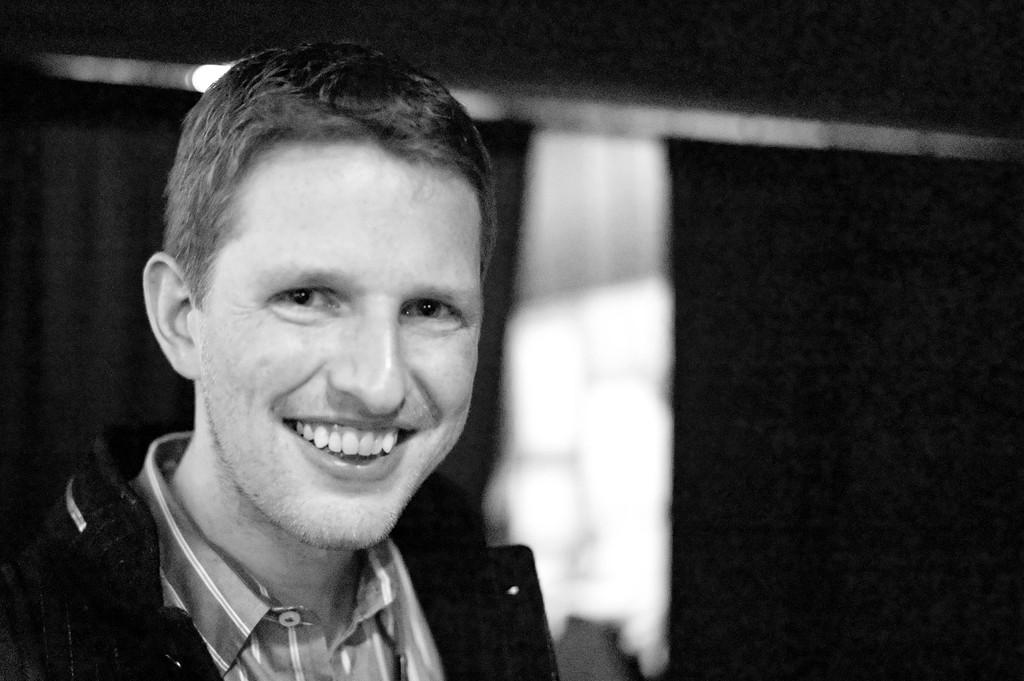Who is present in the image? There is a man in the image. What is the man's facial expression? The man is smiling. Can you describe the background of the image? The background of the image is blurred. What is the color scheme of the image? The image is black and white in color. How many crows are perched on the man's shoulder in the image? There are no crows present in the image. What type of expansion is shown in the image? The image does not depict any expansion; it is a portrait of a man. 